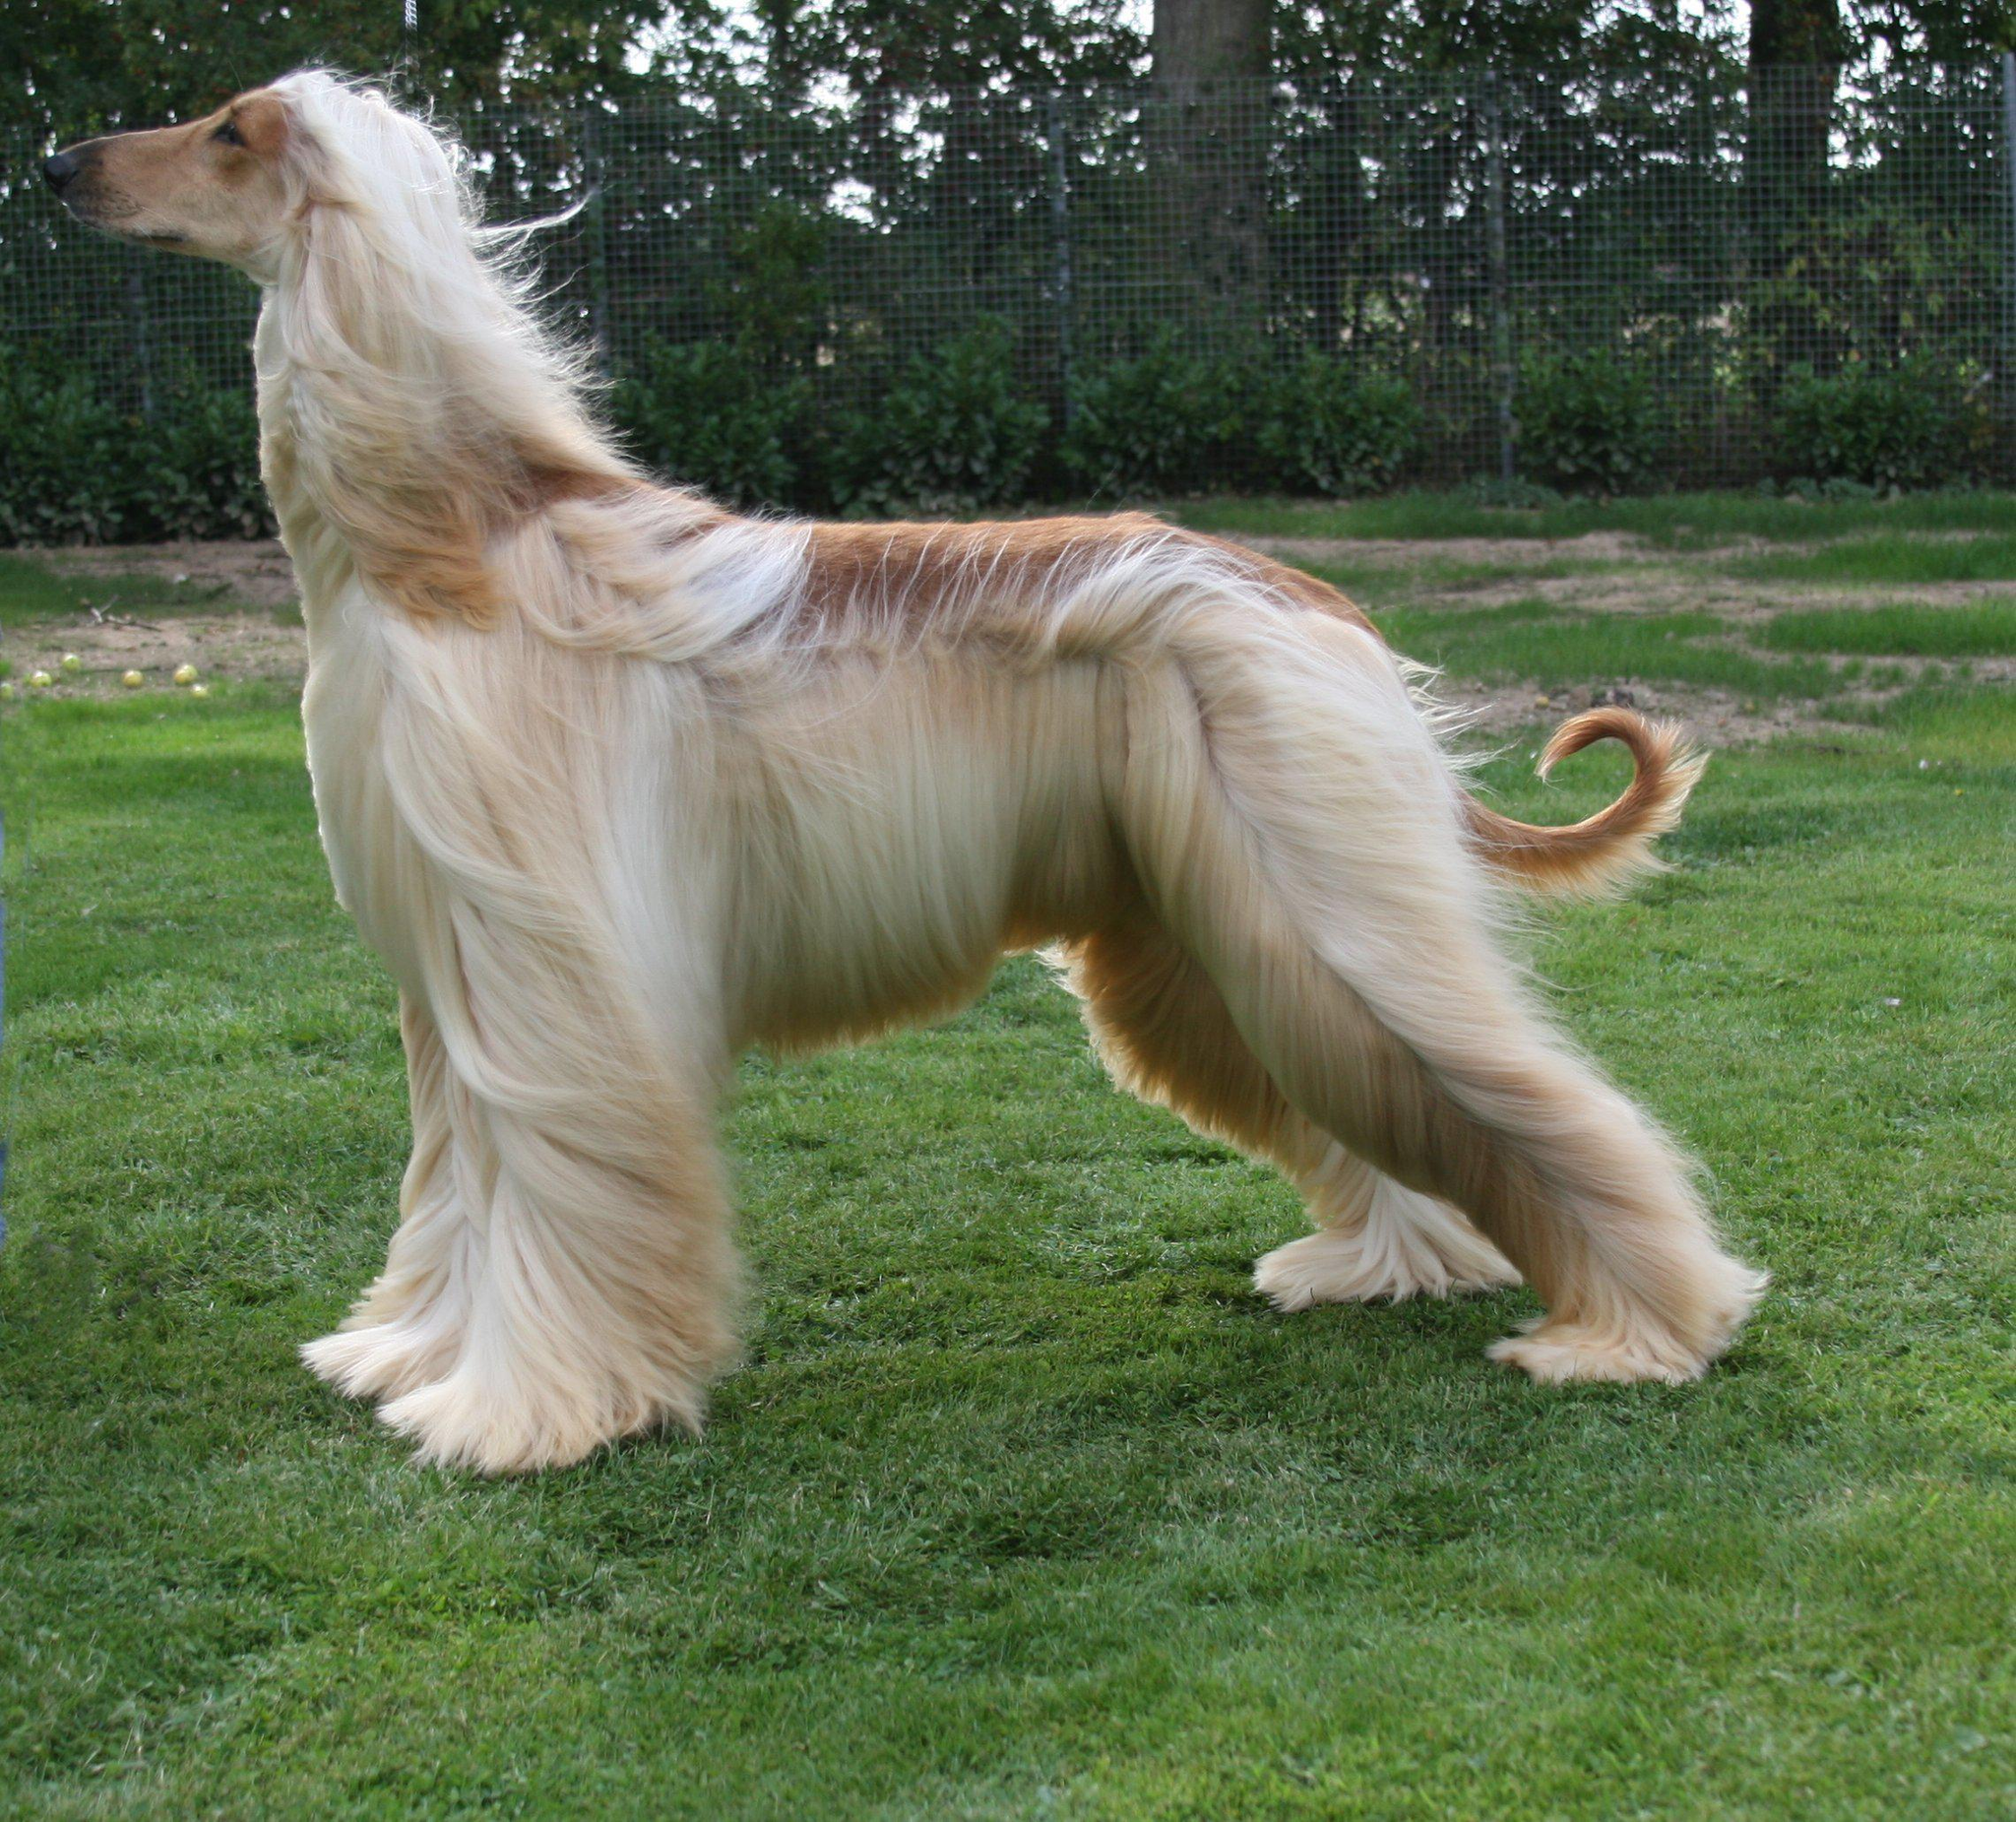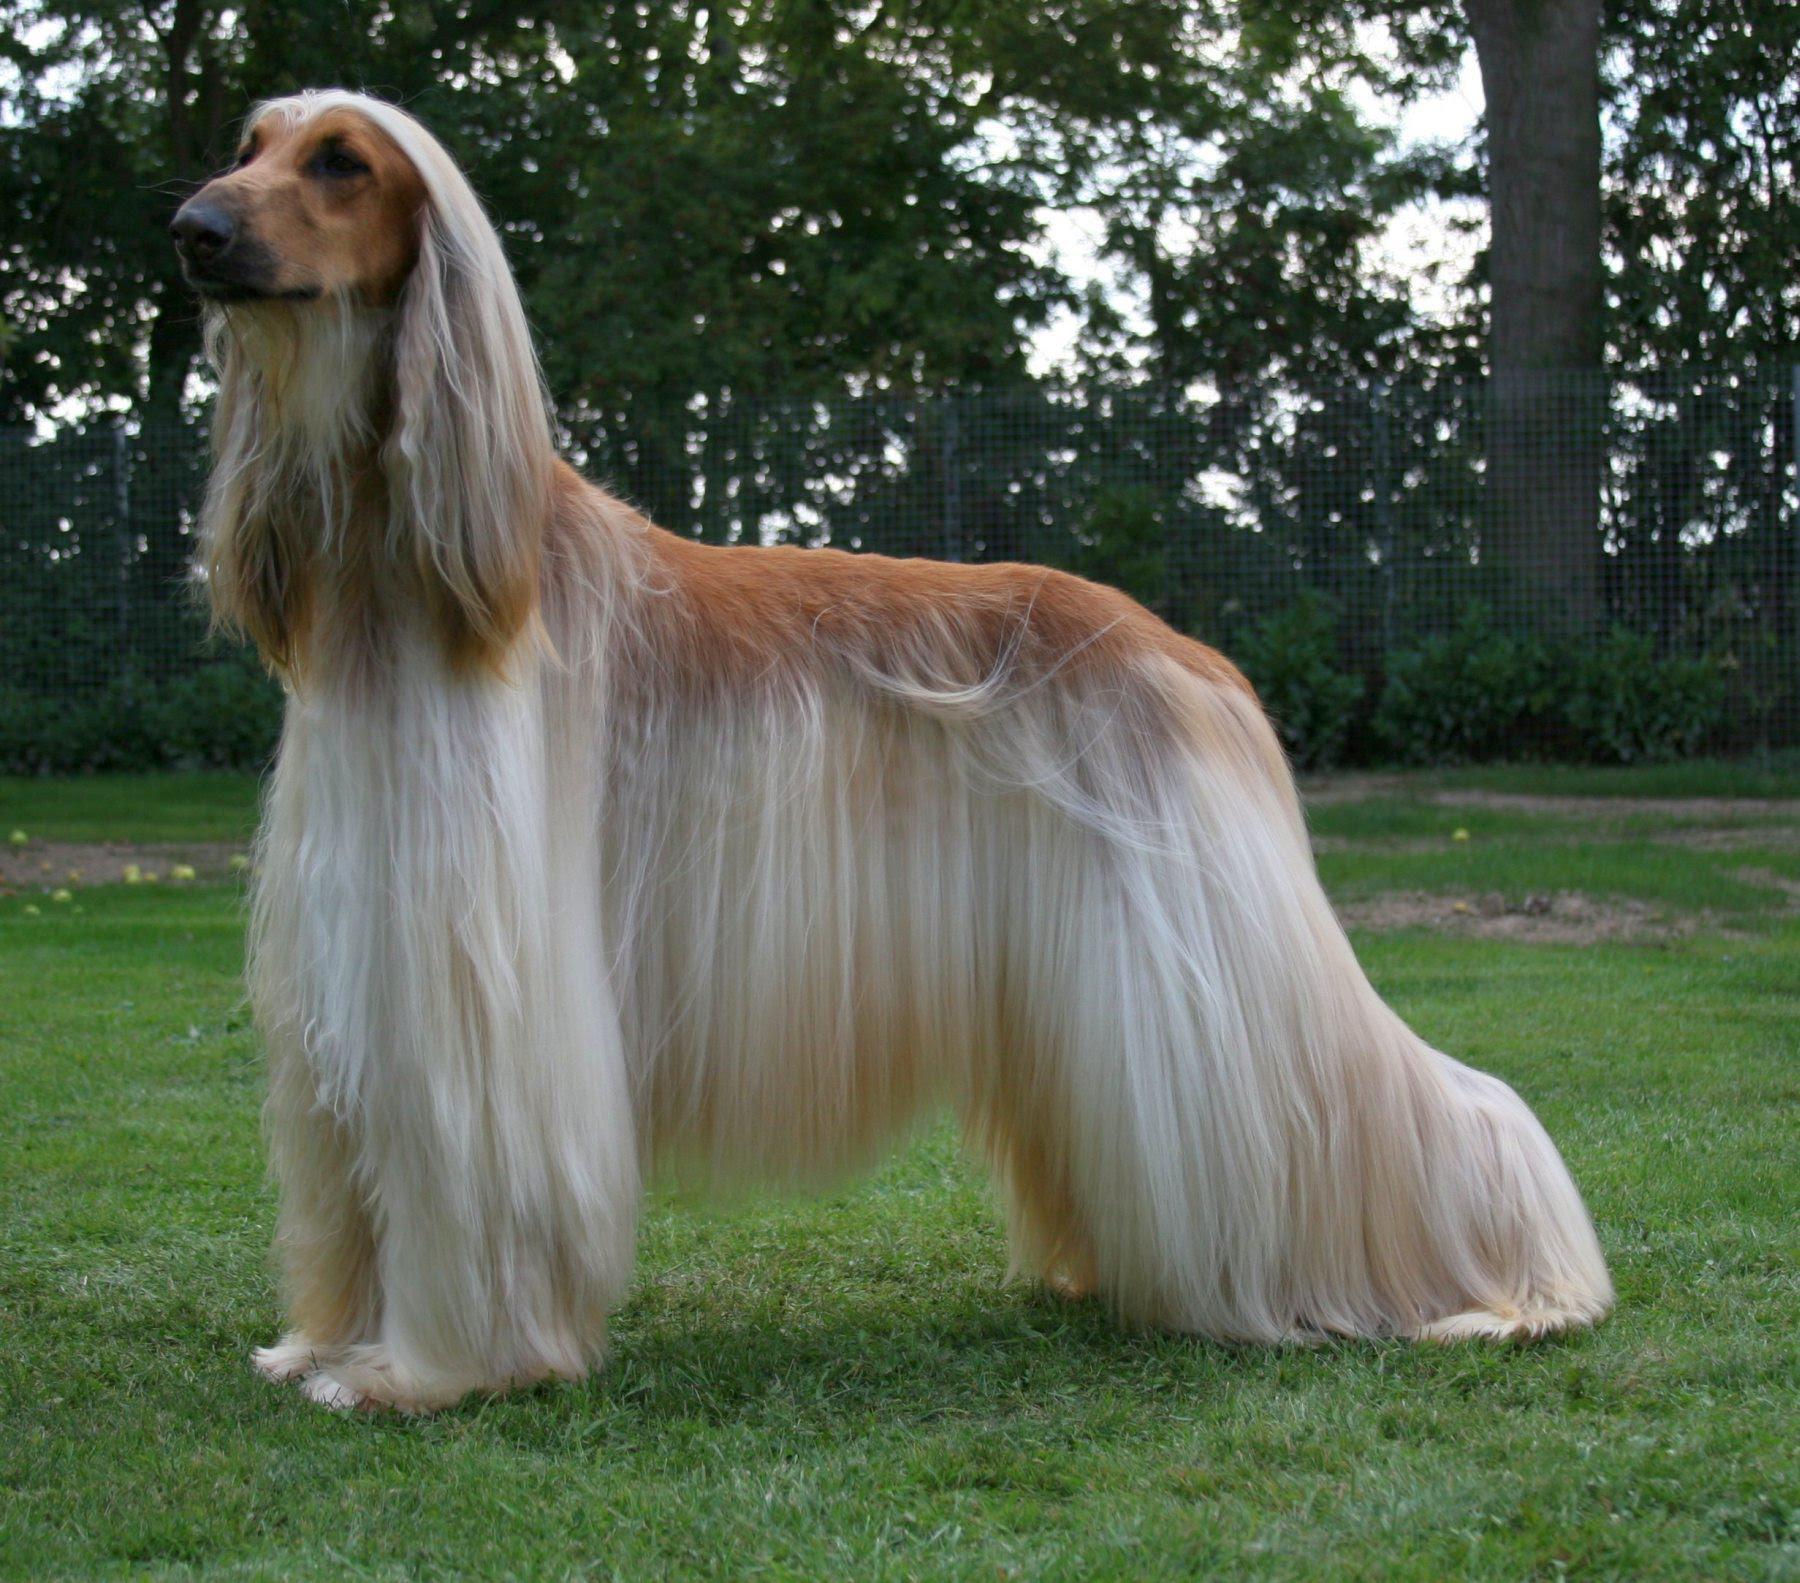The first image is the image on the left, the second image is the image on the right. Evaluate the accuracy of this statement regarding the images: "In one of the images, there is at least one dog sitting down". Is it true? Answer yes or no. No. 